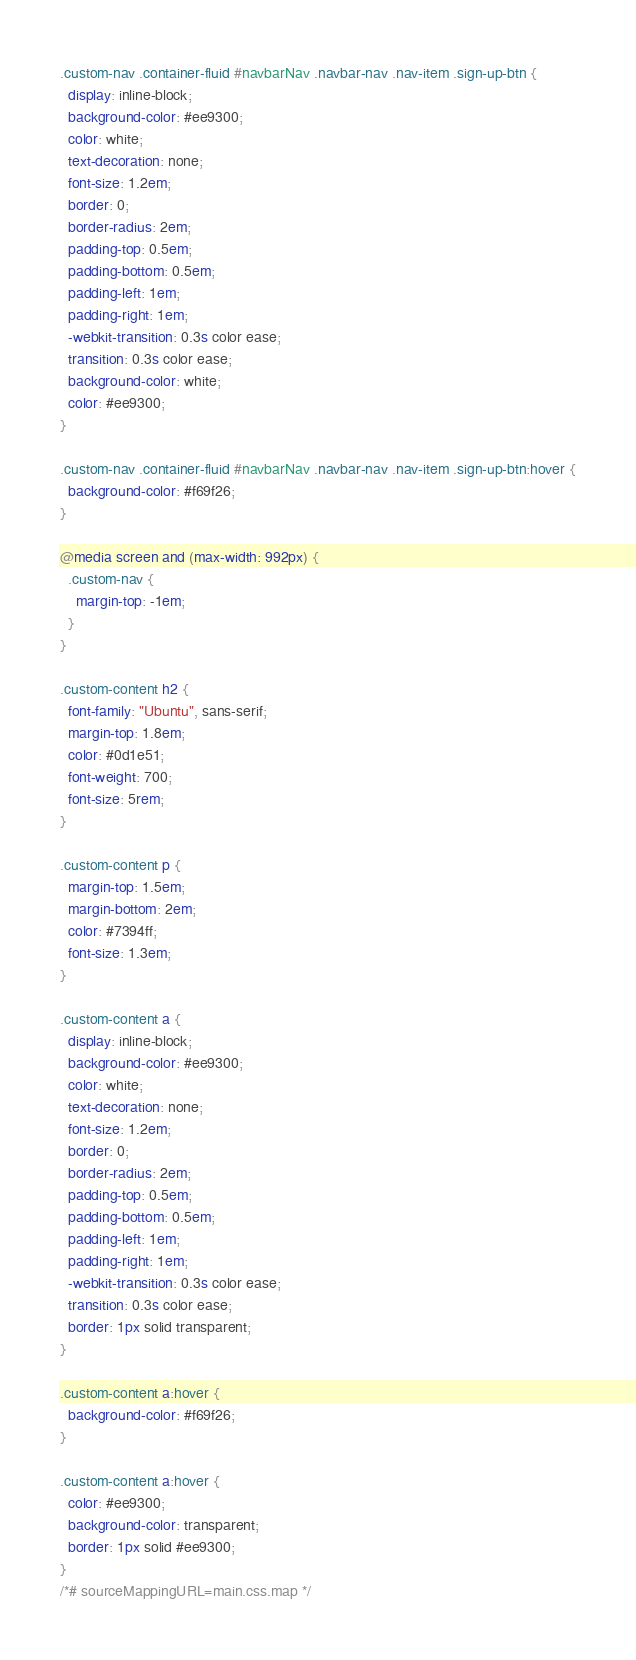Convert code to text. <code><loc_0><loc_0><loc_500><loc_500><_CSS_>
.custom-nav .container-fluid #navbarNav .navbar-nav .nav-item .sign-up-btn {
  display: inline-block;
  background-color: #ee9300;
  color: white;
  text-decoration: none;
  font-size: 1.2em;
  border: 0;
  border-radius: 2em;
  padding-top: 0.5em;
  padding-bottom: 0.5em;
  padding-left: 1em;
  padding-right: 1em;
  -webkit-transition: 0.3s color ease;
  transition: 0.3s color ease;
  background-color: white;
  color: #ee9300;
}

.custom-nav .container-fluid #navbarNav .navbar-nav .nav-item .sign-up-btn:hover {
  background-color: #f69f26;
}

@media screen and (max-width: 992px) {
  .custom-nav {
    margin-top: -1em;
  }
}

.custom-content h2 {
  font-family: "Ubuntu", sans-serif;
  margin-top: 1.8em;
  color: #0d1e51;
  font-weight: 700;
  font-size: 5rem;
}

.custom-content p {
  margin-top: 1.5em;
  margin-bottom: 2em;
  color: #7394ff;
  font-size: 1.3em;
}

.custom-content a {
  display: inline-block;
  background-color: #ee9300;
  color: white;
  text-decoration: none;
  font-size: 1.2em;
  border: 0;
  border-radius: 2em;
  padding-top: 0.5em;
  padding-bottom: 0.5em;
  padding-left: 1em;
  padding-right: 1em;
  -webkit-transition: 0.3s color ease;
  transition: 0.3s color ease;
  border: 1px solid transparent;
}

.custom-content a:hover {
  background-color: #f69f26;
}

.custom-content a:hover {
  color: #ee9300;
  background-color: transparent;
  border: 1px solid #ee9300;
}
/*# sourceMappingURL=main.css.map */</code> 